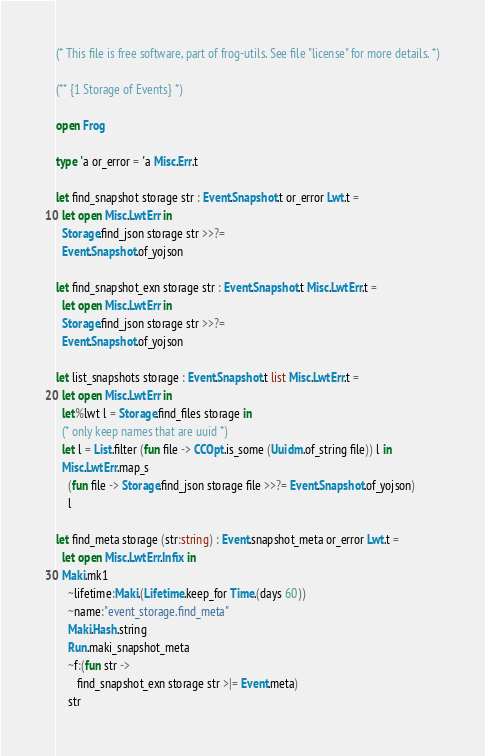<code> <loc_0><loc_0><loc_500><loc_500><_OCaml_>
(* This file is free software, part of frog-utils. See file "license" for more details. *)

(** {1 Storage of Events} *)

open Frog

type 'a or_error = 'a Misc.Err.t

let find_snapshot storage str : Event.Snapshot.t or_error Lwt.t =
  let open Misc.LwtErr in
  Storage.find_json storage str >>?=
  Event.Snapshot.of_yojson

let find_snapshot_exn storage str : Event.Snapshot.t Misc.LwtErr.t =
  let open Misc.LwtErr in
  Storage.find_json storage str >>?=
  Event.Snapshot.of_yojson

let list_snapshots storage : Event.Snapshot.t list Misc.LwtErr.t =
  let open Misc.LwtErr in
  let%lwt l = Storage.find_files storage in
  (* only keep names that are uuid *)
  let l = List.filter (fun file -> CCOpt.is_some (Uuidm.of_string file)) l in
  Misc.LwtErr.map_s
    (fun file -> Storage.find_json storage file >>?= Event.Snapshot.of_yojson)
    l

let find_meta storage (str:string) : Event.snapshot_meta or_error Lwt.t =
  let open Misc.LwtErr.Infix in
  Maki.mk1
    ~lifetime:Maki.(Lifetime.keep_for Time.(days 60))
    ~name:"event_storage.find_meta"
    Maki.Hash.string
    Run.maki_snapshot_meta
    ~f:(fun str ->
       find_snapshot_exn storage str >|= Event.meta)
    str
</code> 